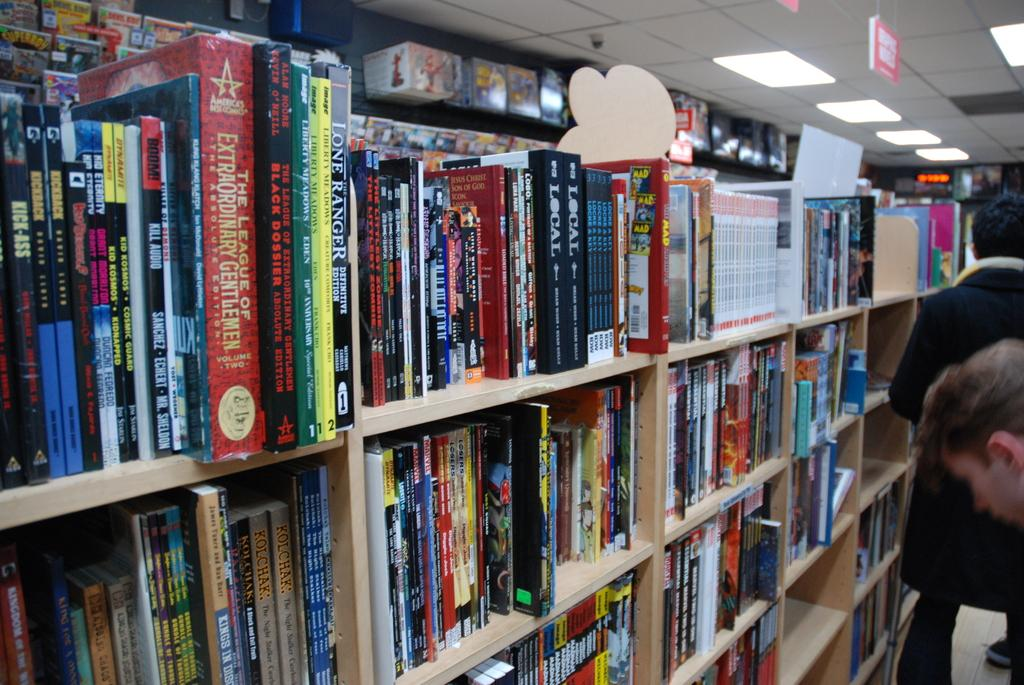<image>
Offer a succinct explanation of the picture presented. A book called The Black Dossier is on a shelf in a book store. 